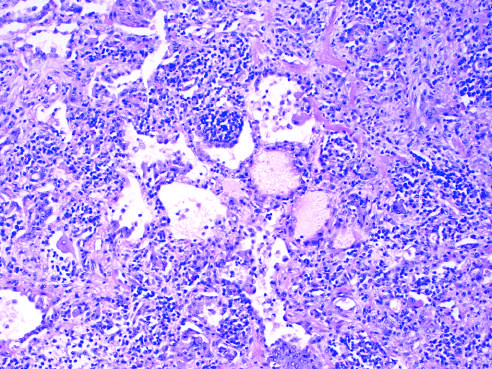what are infiltrated with lymphocytes and some plasma cells, which spill over into alveolar spaces?
Answer the question using a single word or phrase. The thickened alveolar walls 